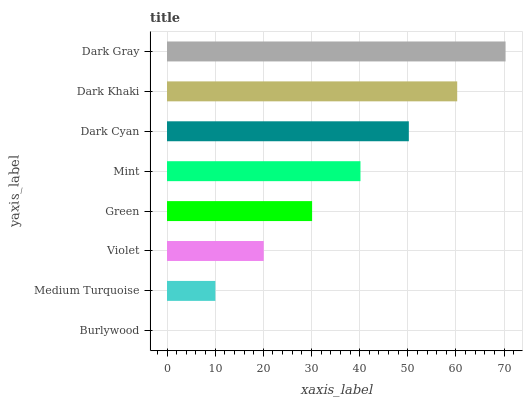Is Burlywood the minimum?
Answer yes or no. Yes. Is Dark Gray the maximum?
Answer yes or no. Yes. Is Medium Turquoise the minimum?
Answer yes or no. No. Is Medium Turquoise the maximum?
Answer yes or no. No. Is Medium Turquoise greater than Burlywood?
Answer yes or no. Yes. Is Burlywood less than Medium Turquoise?
Answer yes or no. Yes. Is Burlywood greater than Medium Turquoise?
Answer yes or no. No. Is Medium Turquoise less than Burlywood?
Answer yes or no. No. Is Mint the high median?
Answer yes or no. Yes. Is Green the low median?
Answer yes or no. Yes. Is Dark Khaki the high median?
Answer yes or no. No. Is Burlywood the low median?
Answer yes or no. No. 